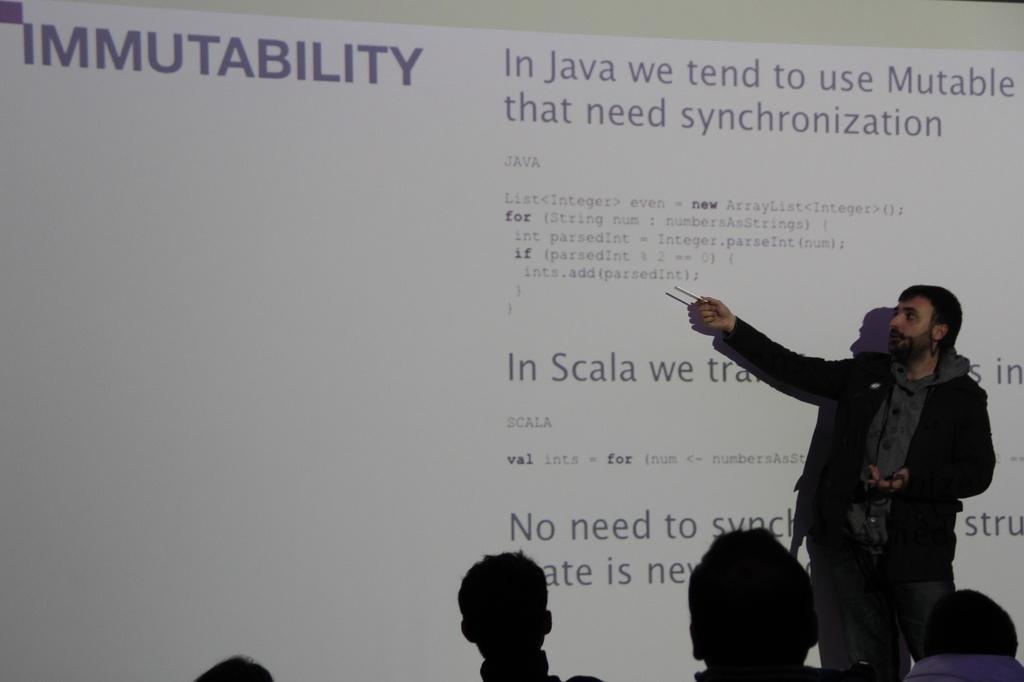In one or two sentences, can you explain what this image depicts? In this image on the right side there is one person standing and he is explaining something. In the background there is a board, on the board there is some text and at the bottom there are some people. 